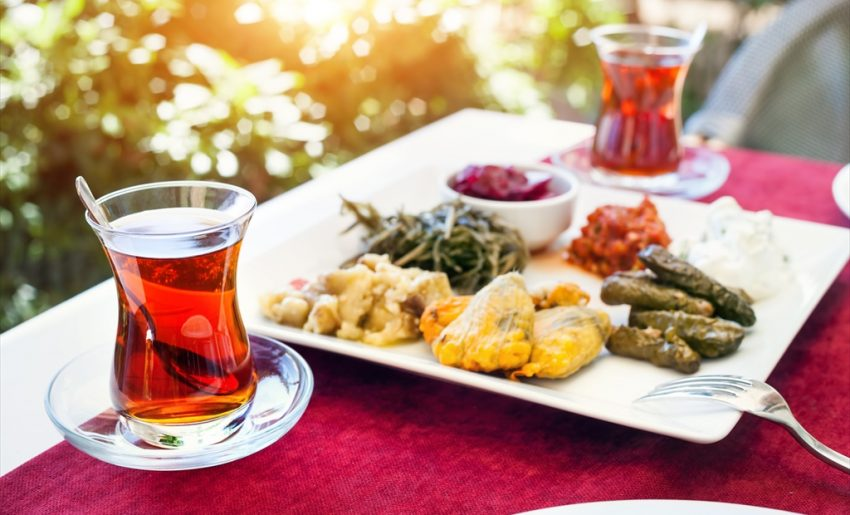How might the choice of beverages complement the meal shown here? The choice of a deep amber, transparent tea in this setting is an excellent complement to the meal. This style of tea, often enjoyed in the Middle East and Mediterranean, particularly Turkey, balances the rich and diverse flavors present in the food. Its slight bitterness and robust nature can cut through the fattiness of any fried items or richness of the dips, while also aiding in digestion. The warmth of the tea additionally sets a comforting tone, making it a staple in these communal, diverse meals. 